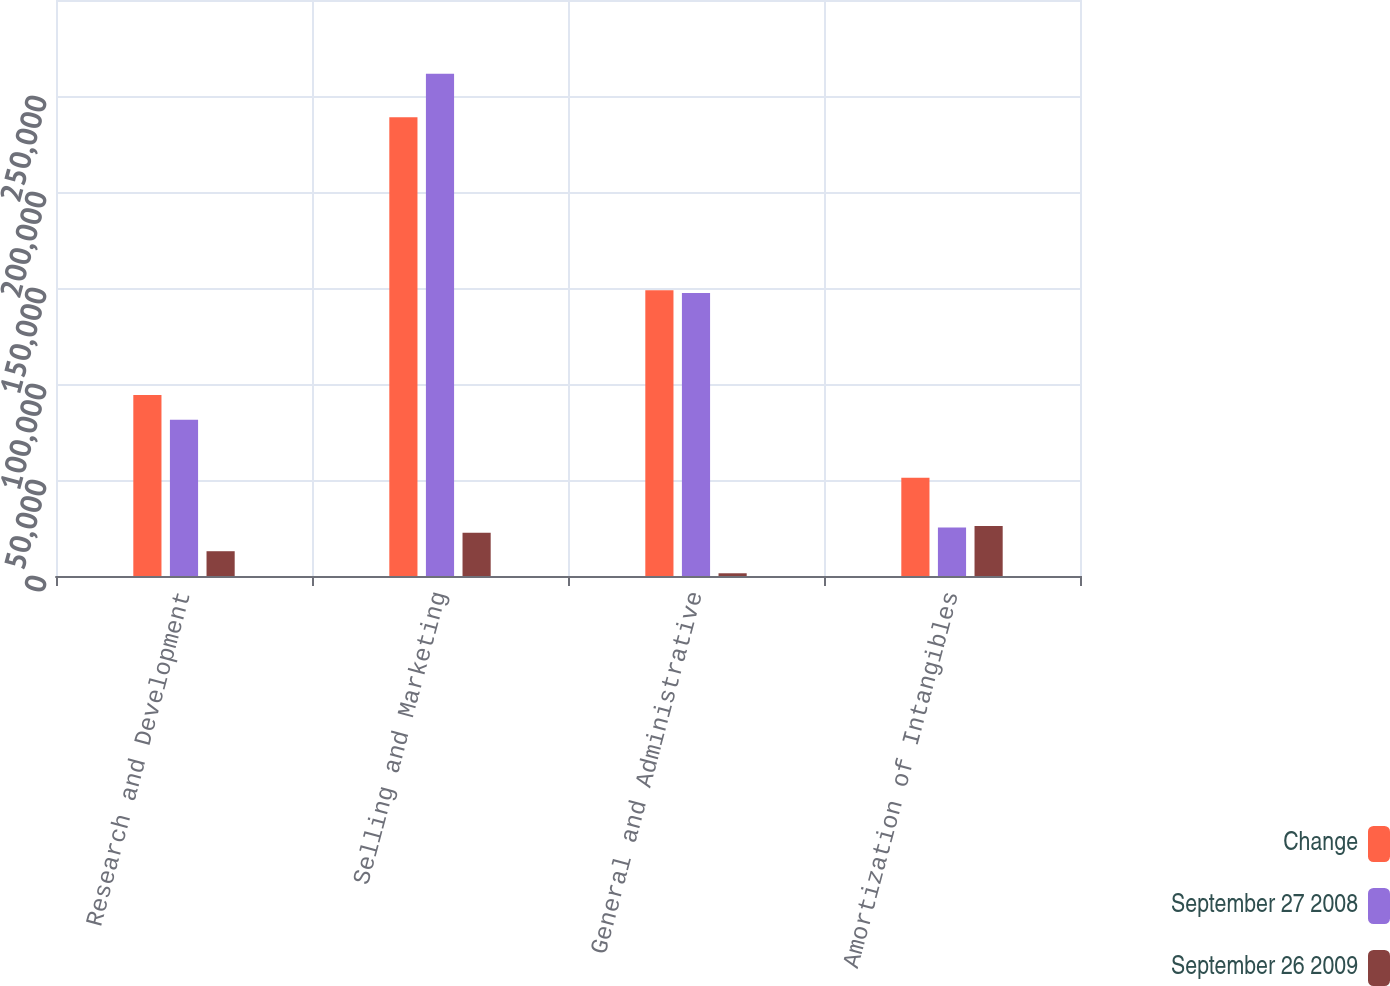Convert chart. <chart><loc_0><loc_0><loc_500><loc_500><stacked_bar_chart><ecel><fcel>Research and Development<fcel>Selling and Marketing<fcel>General and Administrative<fcel>Amortization of Intangibles<nl><fcel>Change<fcel>94328<fcel>238977<fcel>148824<fcel>51210<nl><fcel>September 27 2008<fcel>81421<fcel>261524<fcel>147405<fcel>25227<nl><fcel>September 26 2009<fcel>12907<fcel>22547<fcel>1419<fcel>25983<nl></chart> 